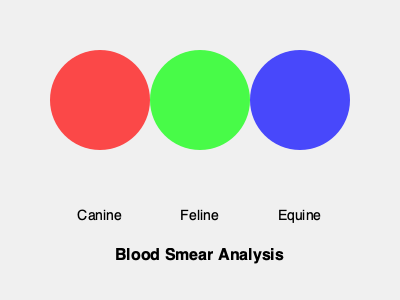Based on the blood smear analysis represented in the diagram, which animal species shows the highest likelihood of parasitic infection, and what statistical measure would be most appropriate to quantify this difference across species? 1. Interpret the diagram:
   - Each circle represents blood smear analysis for a different animal species.
   - The opacity of the circles indicates the likelihood of parasitic infection.

2. Analyze the opacity levels:
   - Canine (red): Highest opacity
   - Feline (green): Medium opacity
   - Equine (blue): Lowest opacity

3. Determine the species with the highest likelihood:
   - The canine sample has the highest opacity, indicating the greatest likelihood of parasitic infection.

4. Consider appropriate statistical measures:
   - To quantify the difference across species, we need a measure that can compare proportions or rates.
   - The most suitable measure would be the odds ratio (OR) or relative risk (RR).

5. Justify the choice of statistical measure:
   - Odds ratio (OR) compares the odds of parasitic infection in one species to another.
   - Relative risk (RR) compares the probability of parasitic infection between species.
   - Both OR and RR are appropriate for comparing binary outcomes (infected vs. not infected) across different groups.

6. Application in veterinary research:
   - Using OR or RR allows for quantification of how much more likely parasitic infections are in canines compared to felines or equines.
   - This information can guide further research into species-specific parasite prevention and treatment strategies.
Answer: Canine; Odds Ratio (OR) or Relative Risk (RR) 